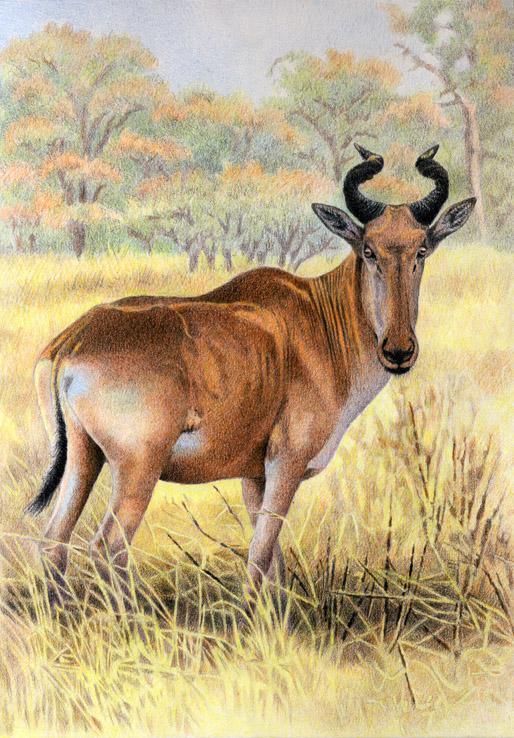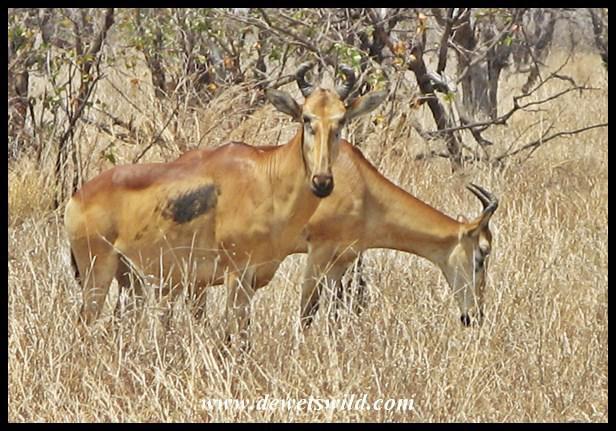The first image is the image on the left, the second image is the image on the right. Analyze the images presented: Is the assertion "There are exactly two animals." valid? Answer yes or no. No. The first image is the image on the left, the second image is the image on the right. For the images displayed, is the sentence "There are at most 2 animals in the image pair" factually correct? Answer yes or no. No. 